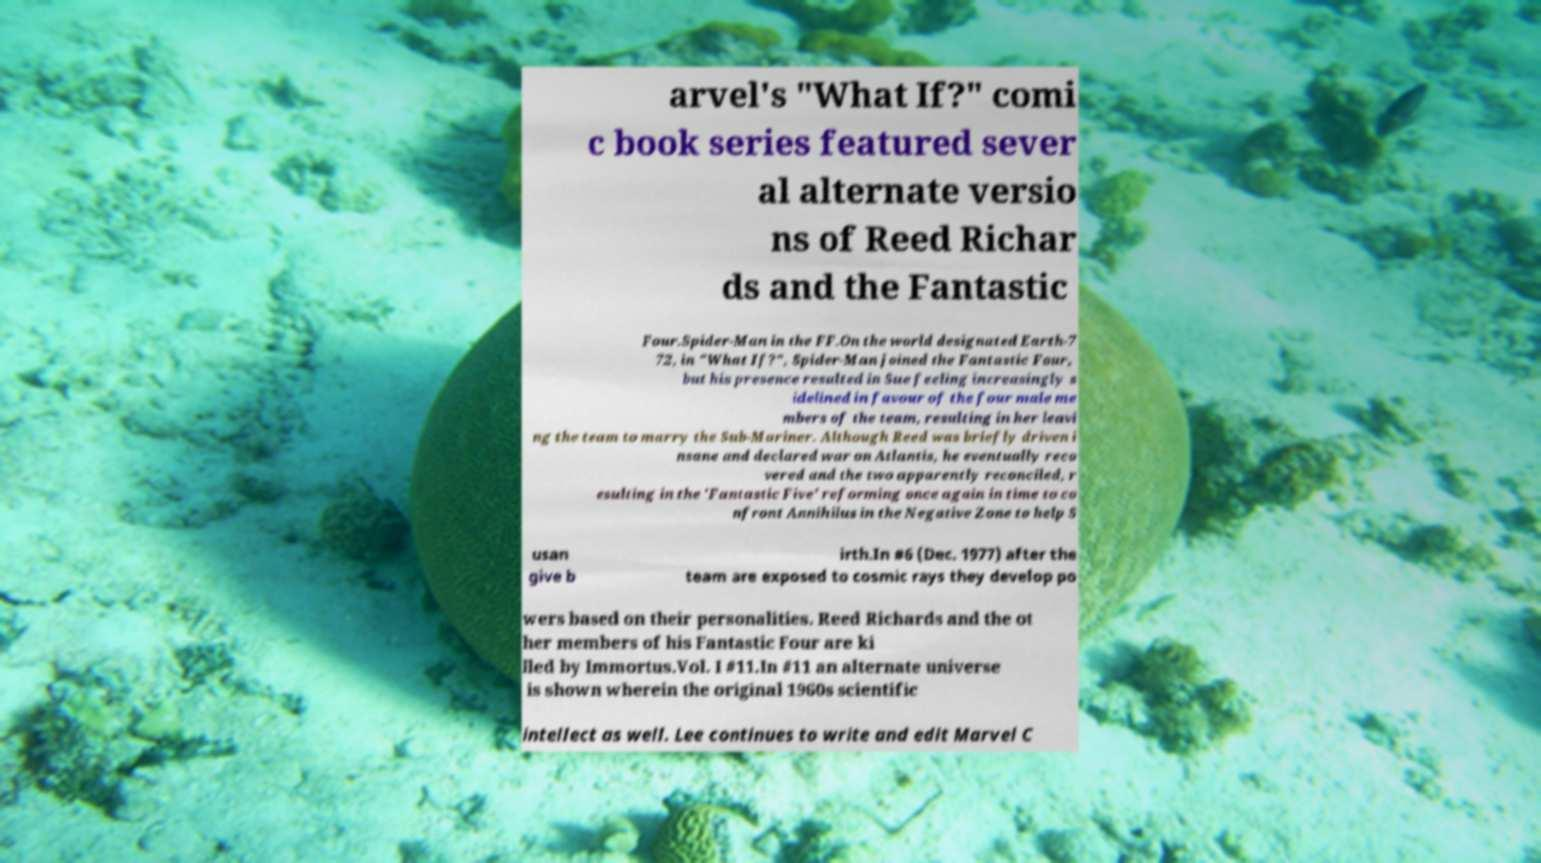For documentation purposes, I need the text within this image transcribed. Could you provide that? arvel's "What If?" comi c book series featured sever al alternate versio ns of Reed Richar ds and the Fantastic Four.Spider-Man in the FF.On the world designated Earth-7 72, in "What If?", Spider-Man joined the Fantastic Four, but his presence resulted in Sue feeling increasingly s idelined in favour of the four male me mbers of the team, resulting in her leavi ng the team to marry the Sub-Mariner. Although Reed was briefly driven i nsane and declared war on Atlantis, he eventually reco vered and the two apparently reconciled, r esulting in the 'Fantastic Five' reforming once again in time to co nfront Annihilus in the Negative Zone to help S usan give b irth.In #6 (Dec. 1977) after the team are exposed to cosmic rays they develop po wers based on their personalities. Reed Richards and the ot her members of his Fantastic Four are ki lled by Immortus.Vol. I #11.In #11 an alternate universe is shown wherein the original 1960s scientific intellect as well. Lee continues to write and edit Marvel C 